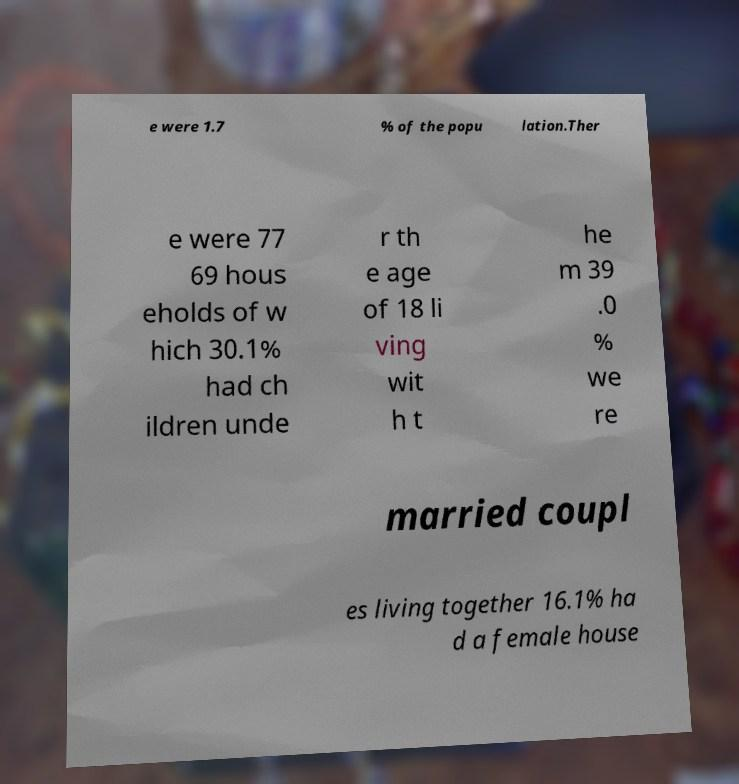There's text embedded in this image that I need extracted. Can you transcribe it verbatim? e were 1.7 % of the popu lation.Ther e were 77 69 hous eholds of w hich 30.1% had ch ildren unde r th e age of 18 li ving wit h t he m 39 .0 % we re married coupl es living together 16.1% ha d a female house 